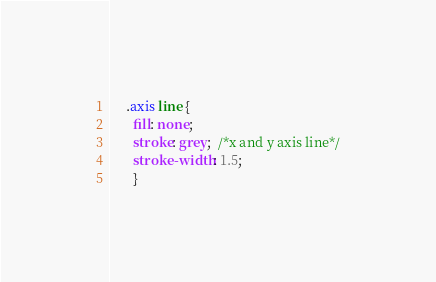<code> <loc_0><loc_0><loc_500><loc_500><_CSS_>     .axis line {
       fill: none;
       stroke: grey;  /*x and y axis line*/
       stroke-width: 1.5;
       }
</code> 